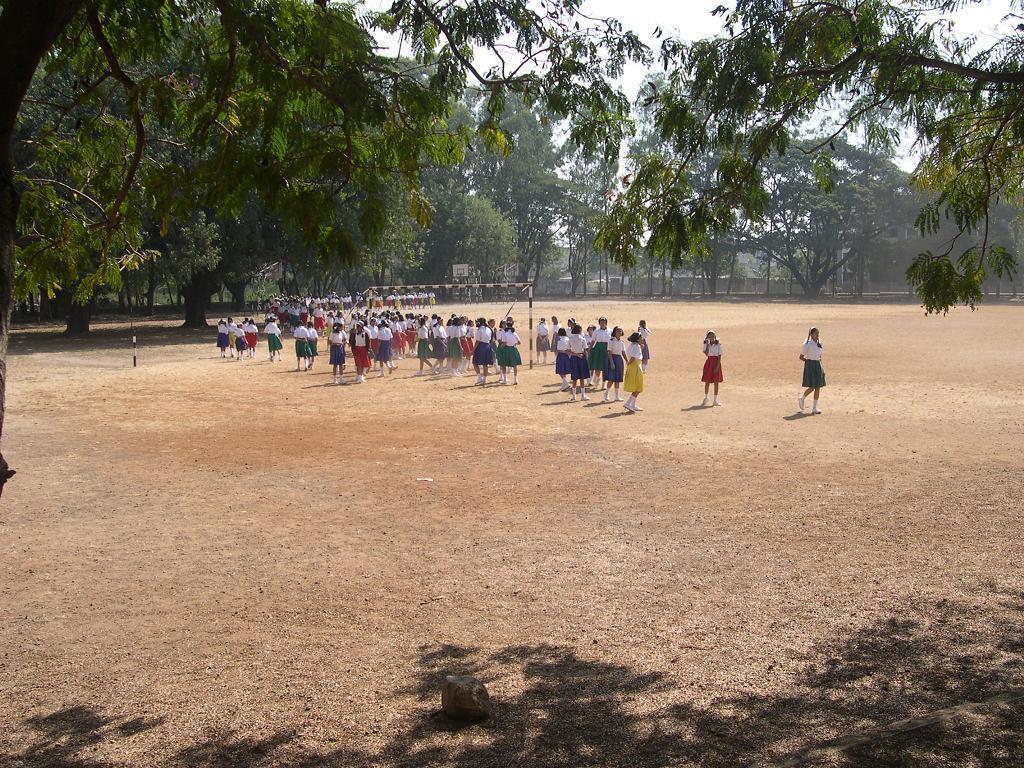Can you describe this image briefly? In this picture we can see a group of people on the path. There are few trees in the background. 